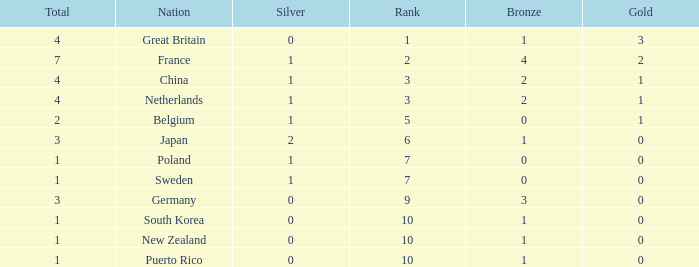Would you mind parsing the complete table? {'header': ['Total', 'Nation', 'Silver', 'Rank', 'Bronze', 'Gold'], 'rows': [['4', 'Great Britain', '0', '1', '1', '3'], ['7', 'France', '1', '2', '4', '2'], ['4', 'China', '1', '3', '2', '1'], ['4', 'Netherlands', '1', '3', '2', '1'], ['2', 'Belgium', '1', '5', '0', '1'], ['3', 'Japan', '2', '6', '1', '0'], ['1', 'Poland', '1', '7', '0', '0'], ['1', 'Sweden', '1', '7', '0', '0'], ['3', 'Germany', '0', '9', '3', '0'], ['1', 'South Korea', '0', '10', '1', '0'], ['1', 'New Zealand', '0', '10', '1', '0'], ['1', 'Puerto Rico', '0', '10', '1', '0']]} What is the smallest number of gold where the total is less than 3 and the silver count is 2? None. 